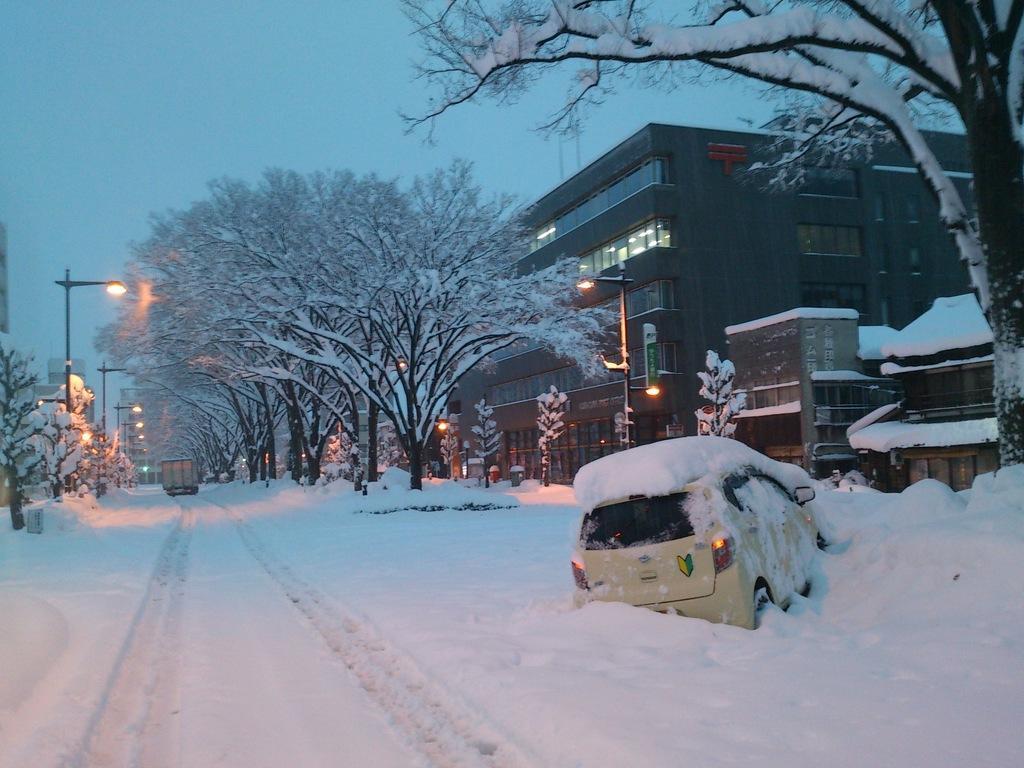In one or two sentences, can you explain what this image depicts? In this picture I can see vehicles, snow, trees, poles, lights, buildings, and in the background there is sky. 